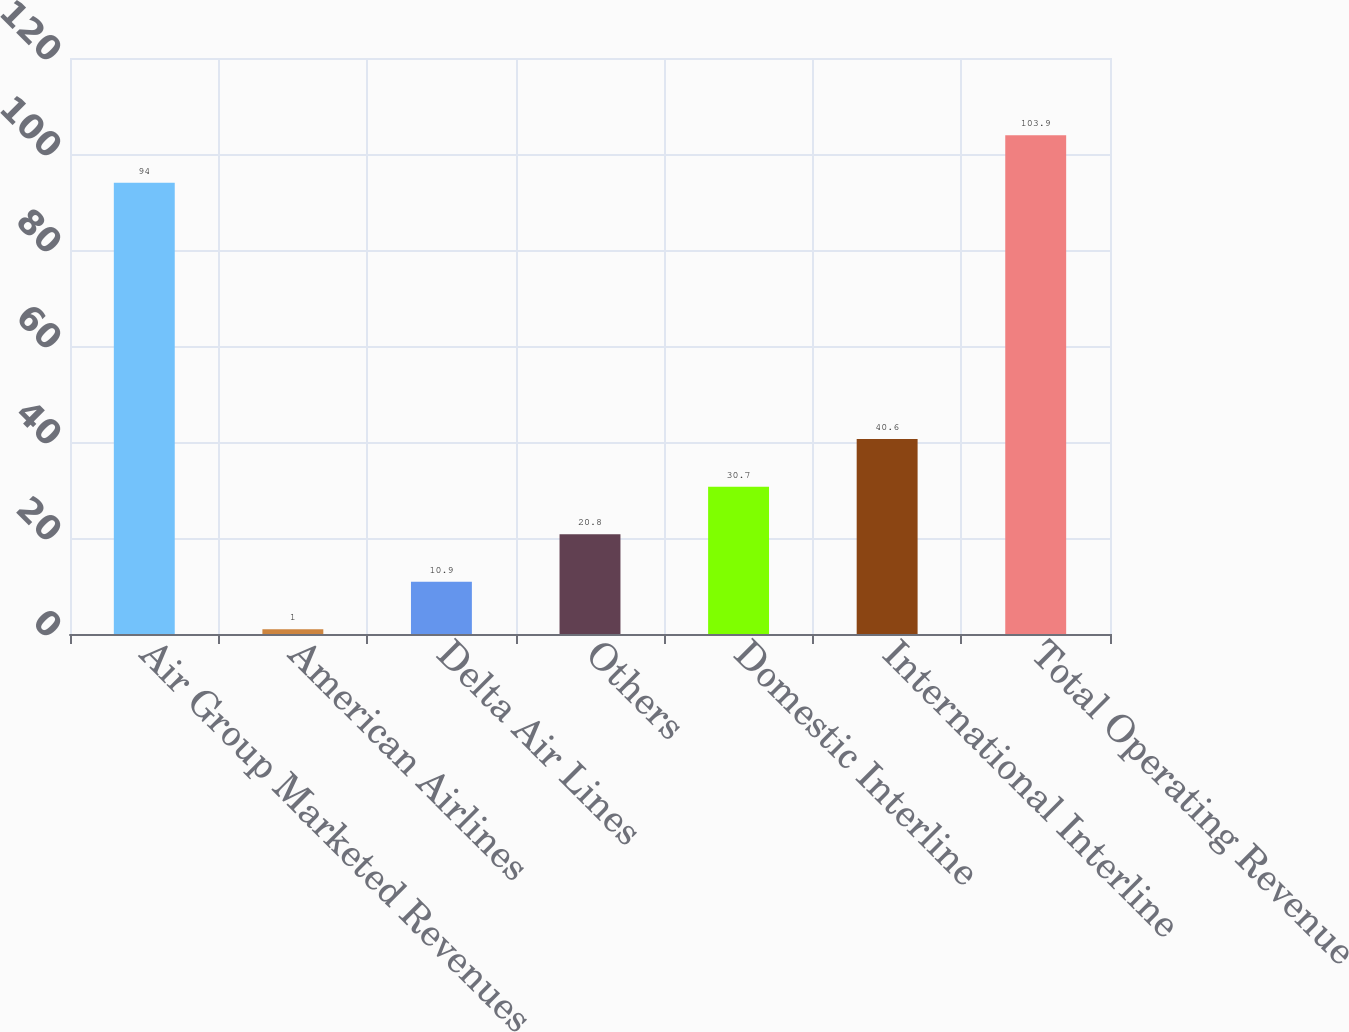Convert chart. <chart><loc_0><loc_0><loc_500><loc_500><bar_chart><fcel>Air Group Marketed Revenues<fcel>American Airlines<fcel>Delta Air Lines<fcel>Others<fcel>Domestic Interline<fcel>International Interline<fcel>Total Operating Revenue<nl><fcel>94<fcel>1<fcel>10.9<fcel>20.8<fcel>30.7<fcel>40.6<fcel>103.9<nl></chart> 